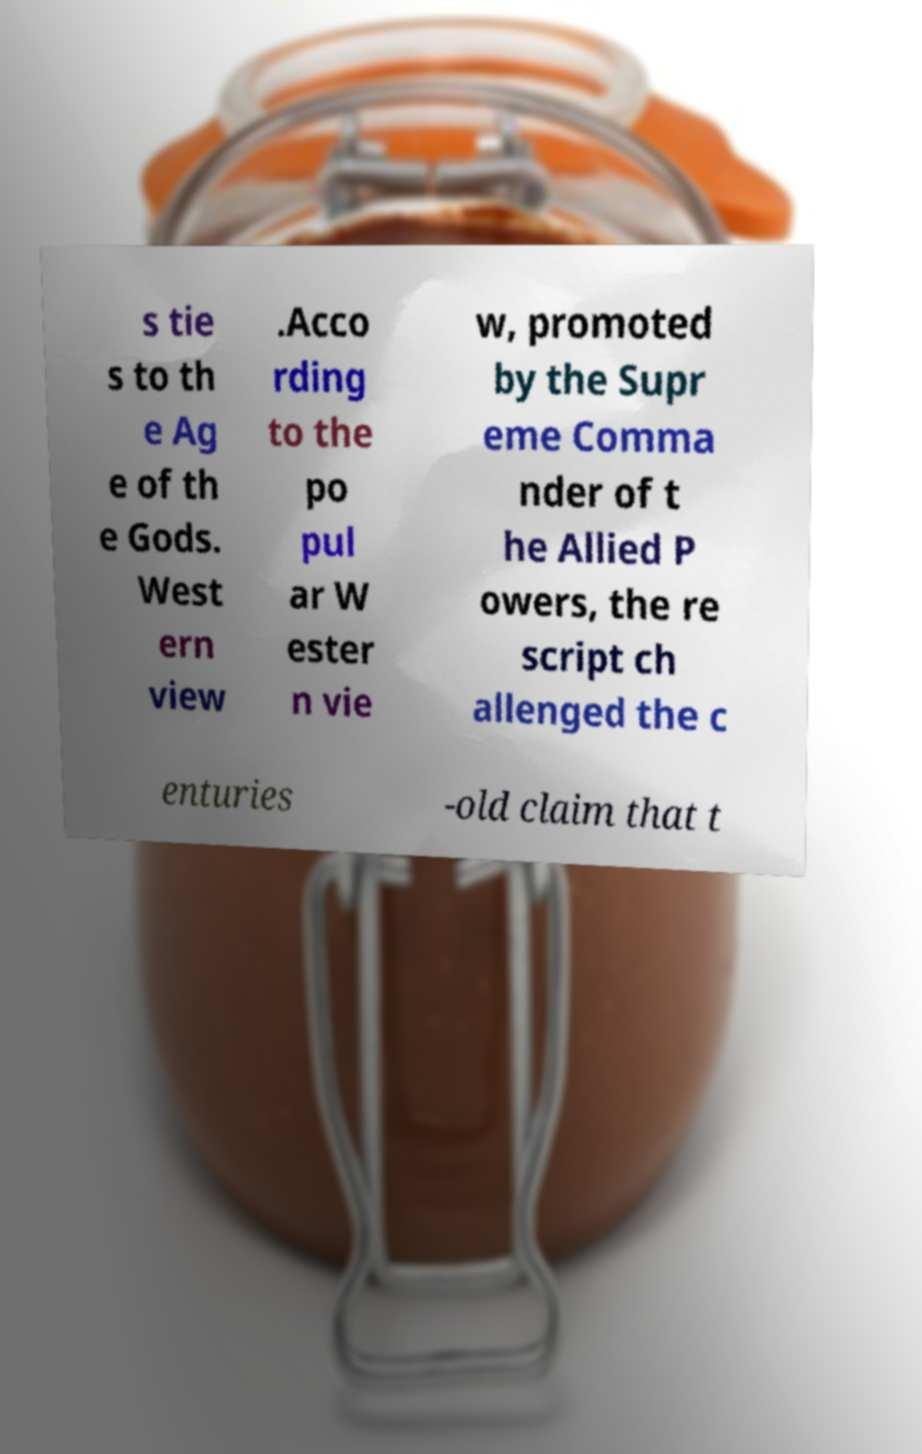I need the written content from this picture converted into text. Can you do that? s tie s to th e Ag e of th e Gods. West ern view .Acco rding to the po pul ar W ester n vie w, promoted by the Supr eme Comma nder of t he Allied P owers, the re script ch allenged the c enturies -old claim that t 